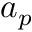<formula> <loc_0><loc_0><loc_500><loc_500>a _ { p }</formula> 